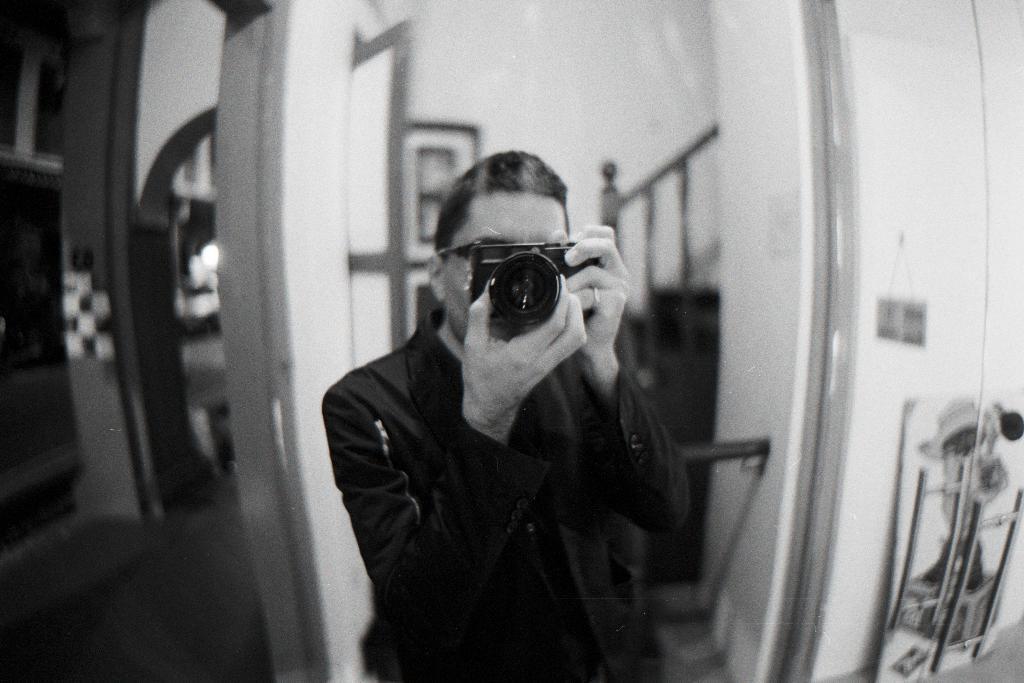Could you give a brief overview of what you see in this image? The image shows that there is a person standing in the center and he is clicking an image with a camera. In the background we can see doors and fence of a staircase which is on the right side. This is looks like a entrance of a kitchen. 